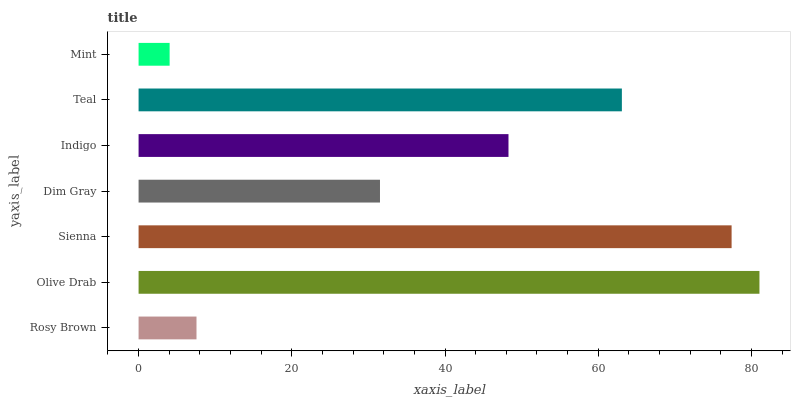Is Mint the minimum?
Answer yes or no. Yes. Is Olive Drab the maximum?
Answer yes or no. Yes. Is Sienna the minimum?
Answer yes or no. No. Is Sienna the maximum?
Answer yes or no. No. Is Olive Drab greater than Sienna?
Answer yes or no. Yes. Is Sienna less than Olive Drab?
Answer yes or no. Yes. Is Sienna greater than Olive Drab?
Answer yes or no. No. Is Olive Drab less than Sienna?
Answer yes or no. No. Is Indigo the high median?
Answer yes or no. Yes. Is Indigo the low median?
Answer yes or no. Yes. Is Teal the high median?
Answer yes or no. No. Is Sienna the low median?
Answer yes or no. No. 